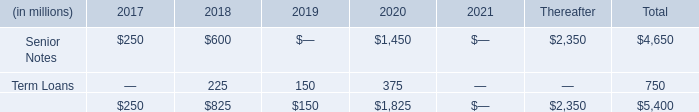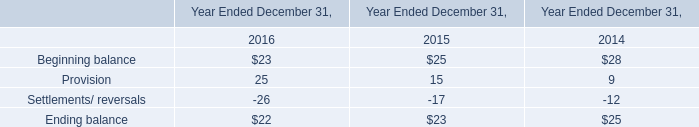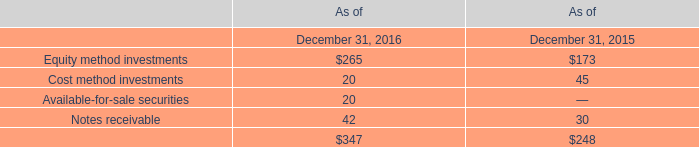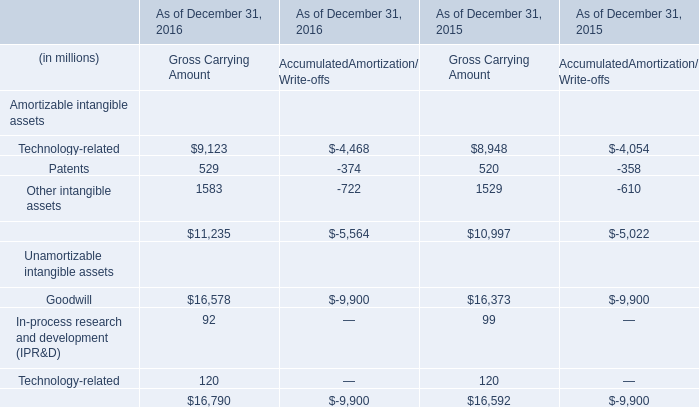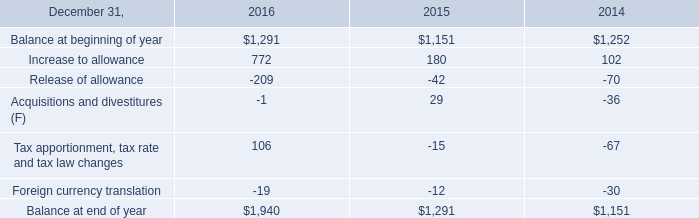What is the growth rate of Goodwill in terms of Gross Carrying Amount between 2016 and 2015? 
Computations: ((16578 - 16373) / 16373)
Answer: 0.01252. 